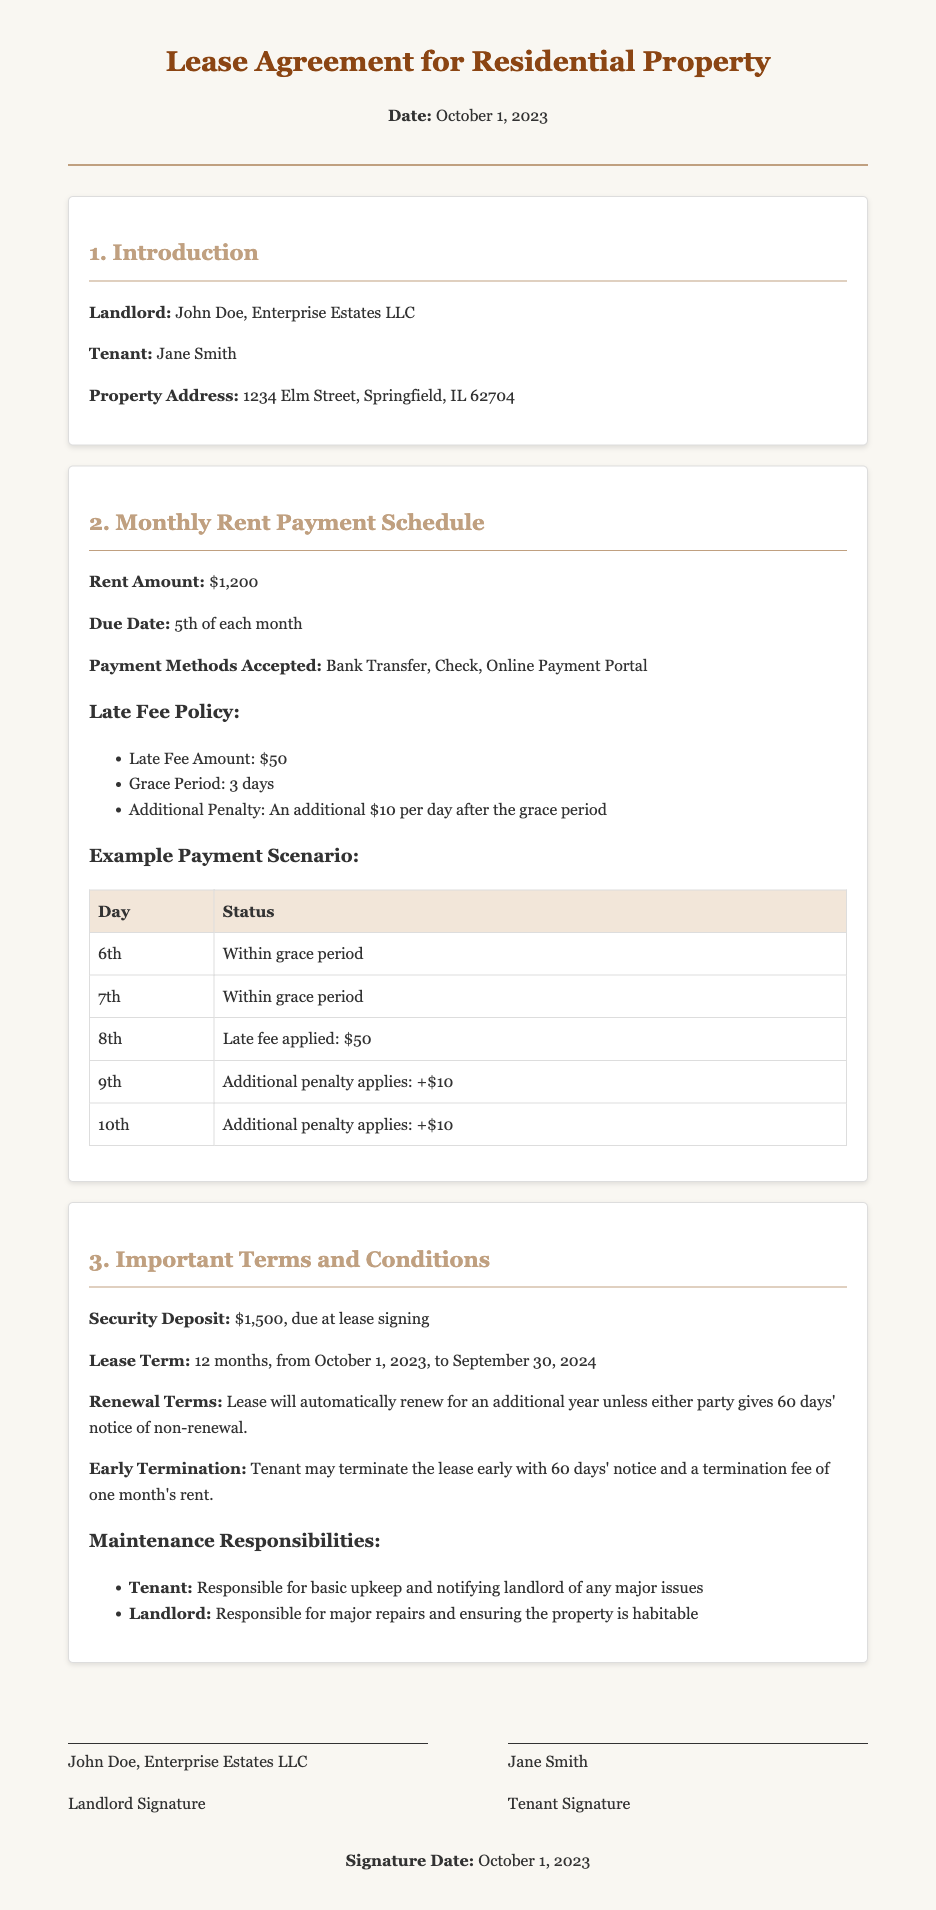What is the rent amount? The rent amount is explicitly stated in the document section under "Monthly Rent Payment Schedule."
Answer: $1,200 What is the due date for the rent? The due date is provided right after the rent amount in the same section.
Answer: 5th of each month What is the late fee amount? This fee is listed under the "Late Fee Policy" within the Monthly Rent Payment Schedule section.
Answer: $50 How many days is the grace period for rent payment? The grace period is included in the late fee policy.
Answer: 3 days What is the security deposit amount? The security deposit amount is detailed under "Important Terms and Conditions."
Answer: $1,500 How long is the lease term? The lease term is specified in the "Important Terms and Conditions" section of the document.
Answer: 12 months When does the lease term begin? This information is detailed in the "Important Terms and Conditions" section, specifying the start date.
Answer: October 1, 2023 What happens if the rent is paid late on the 9th? The penalty for that date is outlined in the example payment scenario.
Answer: Additional penalty applies: +$10 Who is responsible for major repairs? This responsibility is explained under "Maintenance Responsibilities."
Answer: Landlord 